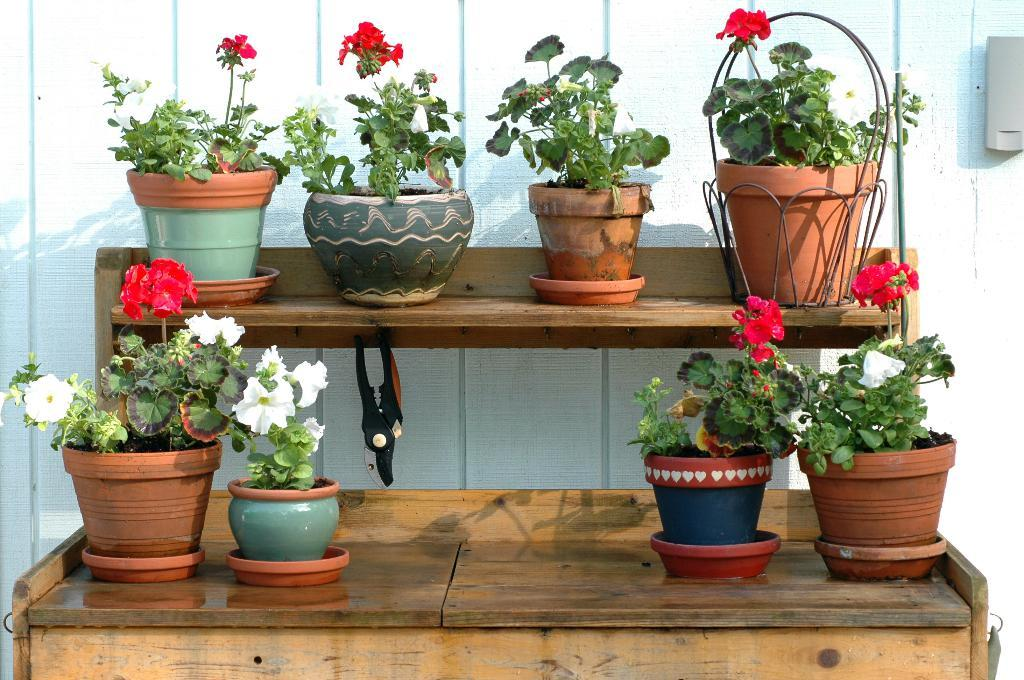What type of plants are in the foreground of the image? There are house plants in the foreground of the image. Where are the house plants placed? The house plants are kept on tables. What can be seen in the background of the image? There is a wall visible in the background of the image. When was the image taken? The image was taken during the day. Where was the image taken? The image was taken outside a house. How many parents are visible in the image? There are no parents present in the image; it features house plants on tables outside a house. What type of cub can be seen playing with the house plants in the image? There is no cub present in the image; it only features house plants on tables outside a house. 